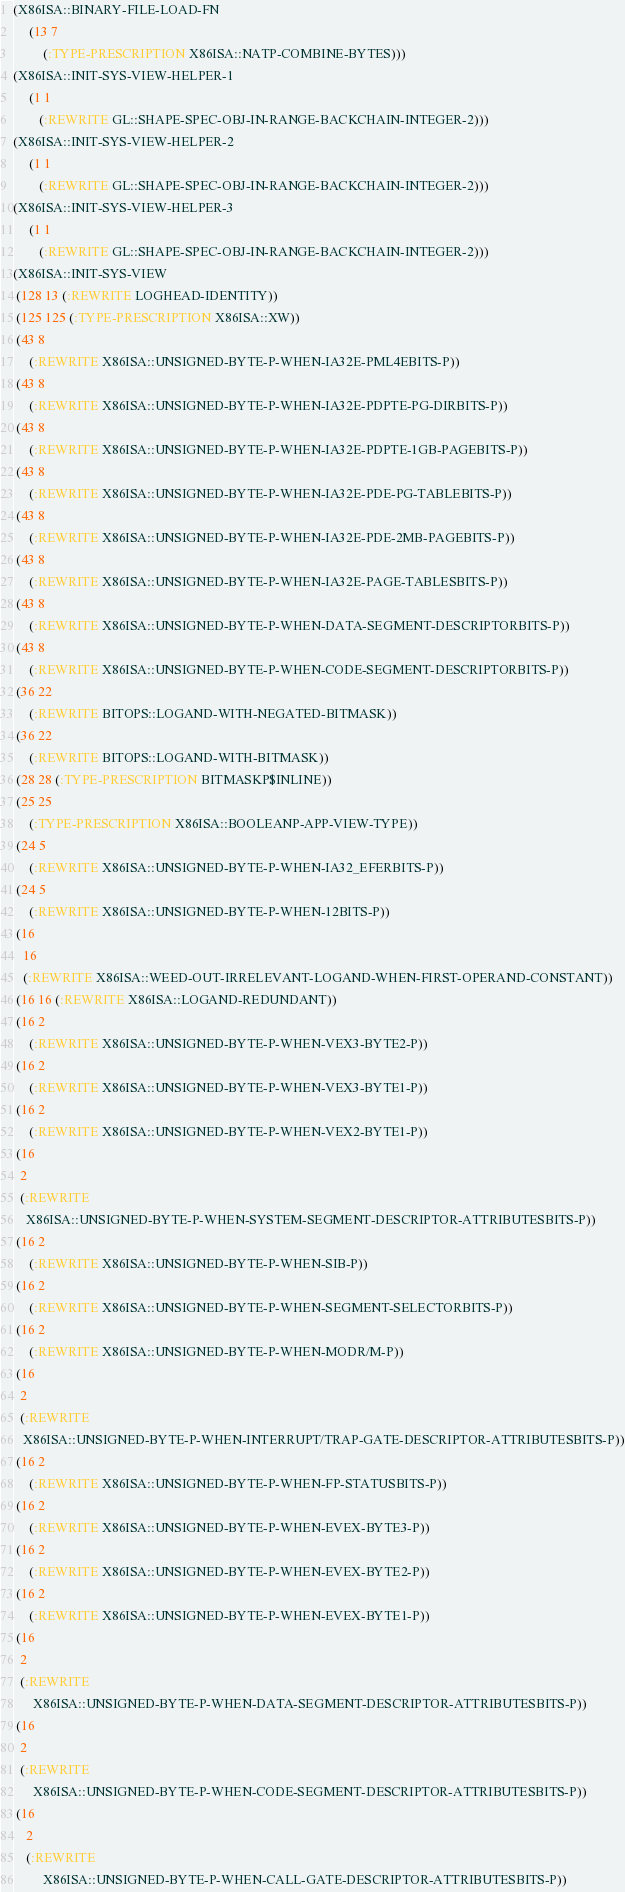<code> <loc_0><loc_0><loc_500><loc_500><_Lisp_>(X86ISA::BINARY-FILE-LOAD-FN
     (13 7
         (:TYPE-PRESCRIPTION X86ISA::NATP-COMBINE-BYTES)))
(X86ISA::INIT-SYS-VIEW-HELPER-1
     (1 1
        (:REWRITE GL::SHAPE-SPEC-OBJ-IN-RANGE-BACKCHAIN-INTEGER-2)))
(X86ISA::INIT-SYS-VIEW-HELPER-2
     (1 1
        (:REWRITE GL::SHAPE-SPEC-OBJ-IN-RANGE-BACKCHAIN-INTEGER-2)))
(X86ISA::INIT-SYS-VIEW-HELPER-3
     (1 1
        (:REWRITE GL::SHAPE-SPEC-OBJ-IN-RANGE-BACKCHAIN-INTEGER-2)))
(X86ISA::INIT-SYS-VIEW
 (128 13 (:REWRITE LOGHEAD-IDENTITY))
 (125 125 (:TYPE-PRESCRIPTION X86ISA::XW))
 (43 8
     (:REWRITE X86ISA::UNSIGNED-BYTE-P-WHEN-IA32E-PML4EBITS-P))
 (43 8
     (:REWRITE X86ISA::UNSIGNED-BYTE-P-WHEN-IA32E-PDPTE-PG-DIRBITS-P))
 (43 8
     (:REWRITE X86ISA::UNSIGNED-BYTE-P-WHEN-IA32E-PDPTE-1GB-PAGEBITS-P))
 (43 8
     (:REWRITE X86ISA::UNSIGNED-BYTE-P-WHEN-IA32E-PDE-PG-TABLEBITS-P))
 (43 8
     (:REWRITE X86ISA::UNSIGNED-BYTE-P-WHEN-IA32E-PDE-2MB-PAGEBITS-P))
 (43 8
     (:REWRITE X86ISA::UNSIGNED-BYTE-P-WHEN-IA32E-PAGE-TABLESBITS-P))
 (43 8
     (:REWRITE X86ISA::UNSIGNED-BYTE-P-WHEN-DATA-SEGMENT-DESCRIPTORBITS-P))
 (43 8
     (:REWRITE X86ISA::UNSIGNED-BYTE-P-WHEN-CODE-SEGMENT-DESCRIPTORBITS-P))
 (36 22
     (:REWRITE BITOPS::LOGAND-WITH-NEGATED-BITMASK))
 (36 22
     (:REWRITE BITOPS::LOGAND-WITH-BITMASK))
 (28 28 (:TYPE-PRESCRIPTION BITMASKP$INLINE))
 (25 25
     (:TYPE-PRESCRIPTION X86ISA::BOOLEANP-APP-VIEW-TYPE))
 (24 5
     (:REWRITE X86ISA::UNSIGNED-BYTE-P-WHEN-IA32_EFERBITS-P))
 (24 5
     (:REWRITE X86ISA::UNSIGNED-BYTE-P-WHEN-12BITS-P))
 (16
   16
   (:REWRITE X86ISA::WEED-OUT-IRRELEVANT-LOGAND-WHEN-FIRST-OPERAND-CONSTANT))
 (16 16 (:REWRITE X86ISA::LOGAND-REDUNDANT))
 (16 2
     (:REWRITE X86ISA::UNSIGNED-BYTE-P-WHEN-VEX3-BYTE2-P))
 (16 2
     (:REWRITE X86ISA::UNSIGNED-BYTE-P-WHEN-VEX3-BYTE1-P))
 (16 2
     (:REWRITE X86ISA::UNSIGNED-BYTE-P-WHEN-VEX2-BYTE1-P))
 (16
  2
  (:REWRITE
    X86ISA::UNSIGNED-BYTE-P-WHEN-SYSTEM-SEGMENT-DESCRIPTOR-ATTRIBUTESBITS-P))
 (16 2
     (:REWRITE X86ISA::UNSIGNED-BYTE-P-WHEN-SIB-P))
 (16 2
     (:REWRITE X86ISA::UNSIGNED-BYTE-P-WHEN-SEGMENT-SELECTORBITS-P))
 (16 2
     (:REWRITE X86ISA::UNSIGNED-BYTE-P-WHEN-MODR/M-P))
 (16
  2
  (:REWRITE
   X86ISA::UNSIGNED-BYTE-P-WHEN-INTERRUPT/TRAP-GATE-DESCRIPTOR-ATTRIBUTESBITS-P))
 (16 2
     (:REWRITE X86ISA::UNSIGNED-BYTE-P-WHEN-FP-STATUSBITS-P))
 (16 2
     (:REWRITE X86ISA::UNSIGNED-BYTE-P-WHEN-EVEX-BYTE3-P))
 (16 2
     (:REWRITE X86ISA::UNSIGNED-BYTE-P-WHEN-EVEX-BYTE2-P))
 (16 2
     (:REWRITE X86ISA::UNSIGNED-BYTE-P-WHEN-EVEX-BYTE1-P))
 (16
  2
  (:REWRITE
      X86ISA::UNSIGNED-BYTE-P-WHEN-DATA-SEGMENT-DESCRIPTOR-ATTRIBUTESBITS-P))
 (16
  2
  (:REWRITE
      X86ISA::UNSIGNED-BYTE-P-WHEN-CODE-SEGMENT-DESCRIPTOR-ATTRIBUTESBITS-P))
 (16
    2
    (:REWRITE
         X86ISA::UNSIGNED-BYTE-P-WHEN-CALL-GATE-DESCRIPTOR-ATTRIBUTESBITS-P))</code> 